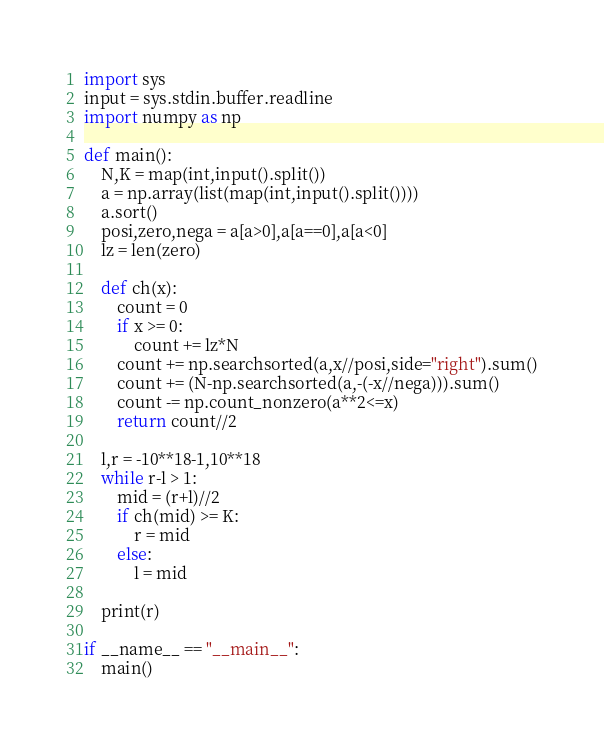<code> <loc_0><loc_0><loc_500><loc_500><_Python_>import sys
input = sys.stdin.buffer.readline
import numpy as np

def main():
    N,K = map(int,input().split())
    a = np.array(list(map(int,input().split())))
    a.sort()
    posi,zero,nega = a[a>0],a[a==0],a[a<0]
    lz = len(zero)
    
    def ch(x):
        count = 0
        if x >= 0:
            count += lz*N
        count += np.searchsorted(a,x//posi,side="right").sum()
        count += (N-np.searchsorted(a,-(-x//nega))).sum()
        count -= np.count_nonzero(a**2<=x)
        return count//2

    l,r = -10**18-1,10**18
    while r-l > 1:
        mid = (r+l)//2
        if ch(mid) >= K:
            r = mid
        else:
            l = mid

    print(r)
    
if __name__ == "__main__":
    main()
</code> 